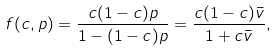Convert formula to latex. <formula><loc_0><loc_0><loc_500><loc_500>f ( c , p ) = \frac { c ( 1 - c ) p } { 1 - ( 1 - c ) p } = \frac { c ( 1 - c ) \bar { v } } { 1 + c \bar { v } } ,</formula> 